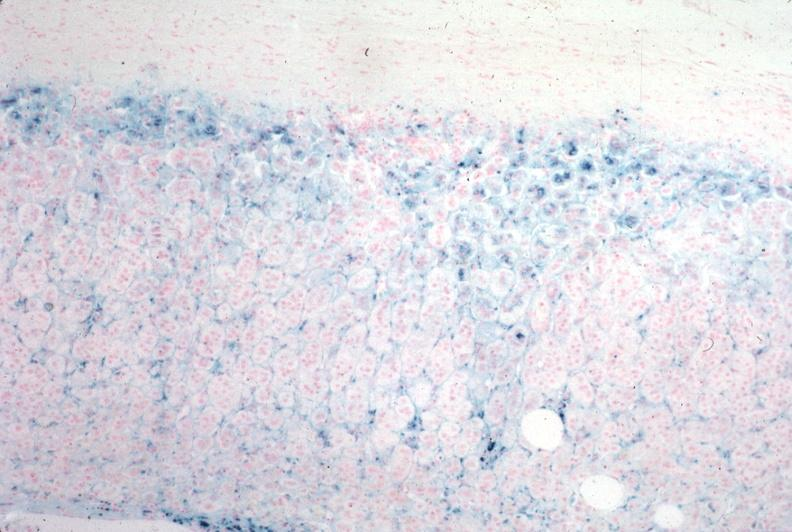s parathyroid present?
Answer the question using a single word or phrase. No 